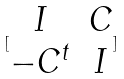<formula> <loc_0><loc_0><loc_500><loc_500>[ \begin{matrix} I & C \\ - C ^ { t } & I \end{matrix} ]</formula> 